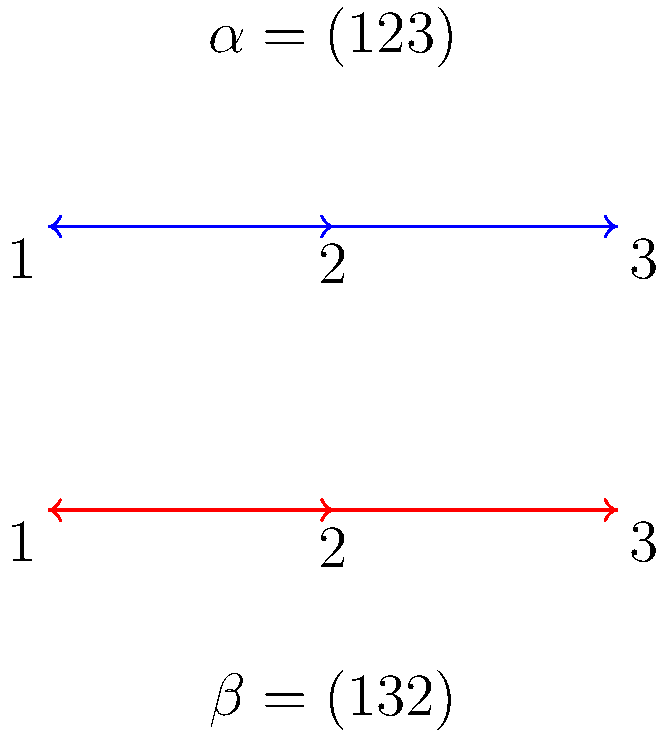In the context of group theory, consider two permutations $\alpha = (123)$ and $\beta = (132)$ represented by the blue and red cycle diagrams, respectively. What is the result of the composition $\alpha \circ \beta$ in cycle notation? To find the composition $\alpha \circ \beta$, we follow these steps:

1. Start with $\beta$: (132)
   This means 1 → 3, 3 → 2, and 2 → 1

2. Then apply $\alpha$: (123)
   This means 1 → 2, 2 → 3, and 3 → 1

3. Trace the path of each element:
   - 1 (from $\beta$) → 3 (from $\alpha$) → 1
   - 2 (from $\beta$) → 1 (from $\alpha$) → 2
   - 3 (from $\beta$) → 2 (from $\alpha$) → 3

4. The result shows that each element maps to itself.

5. In cycle notation, when each element maps to itself, we represent it as the identity permutation.

Therefore, the composition $\alpha \circ \beta$ results in the identity permutation, which is typically denoted as (1) or simply e in group theory.
Answer: (1) or e 